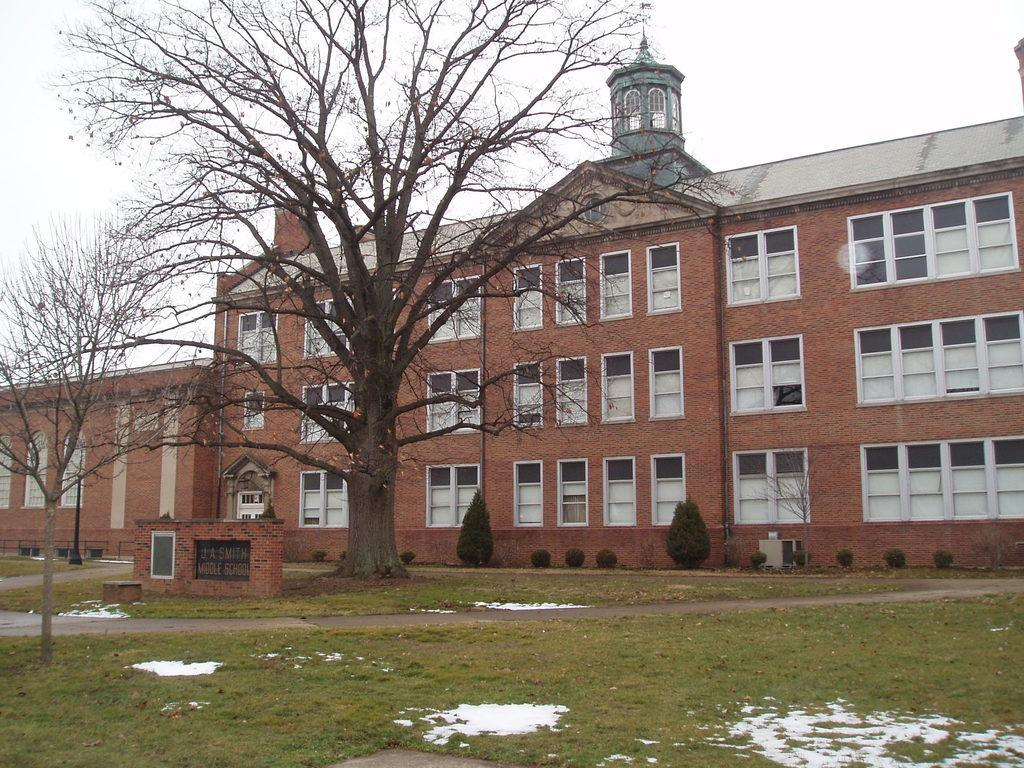What type of structure is visible in the image? There is a building with windows in the image. What can be seen in front of the building? Trees and bushes are in front of the building. Is there any signage or identification for the building? Yes, there is a name board in front of the building. What is the condition of the ground in front of the building? Snow is on the grass in front of the building. What is visible in the background of the image? The sky is visible in the background of the image. Where is the shelf located in the image? There is no shelf present in the image. How does the scene change when the characters push the button? There are no characters or buttons present in the image, so it is not possible to answer this question. 